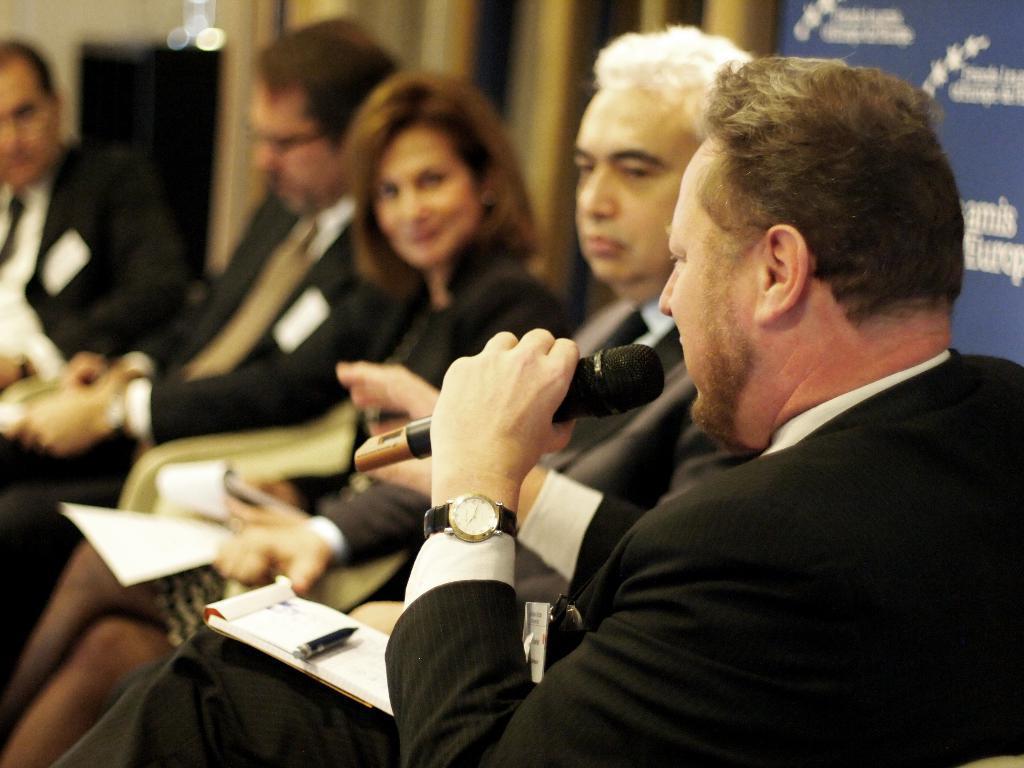In one or two sentences, can you explain what this image depicts? In this picture there are people those who are sitting on the chairs, in the center of the image and there is a person who is sitting on the right side of the image, by holding a mic in his hands. 